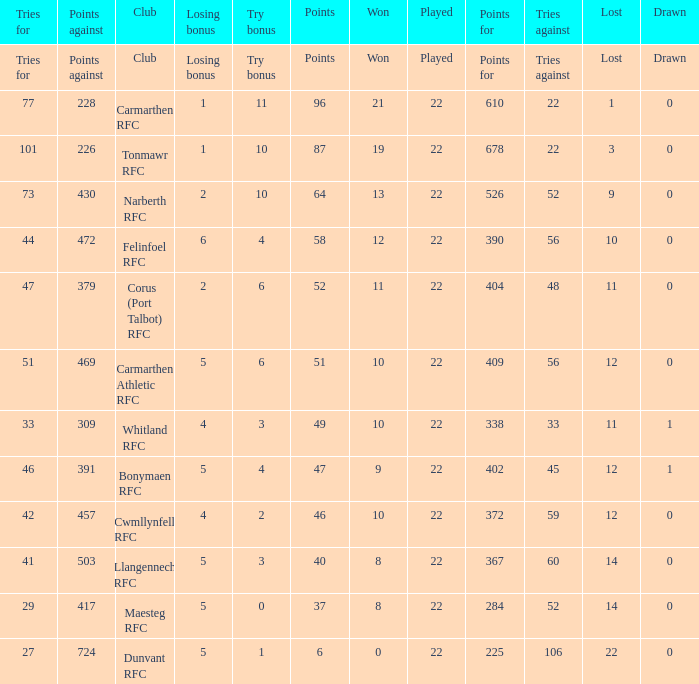Name the points against for 51 points 469.0. 